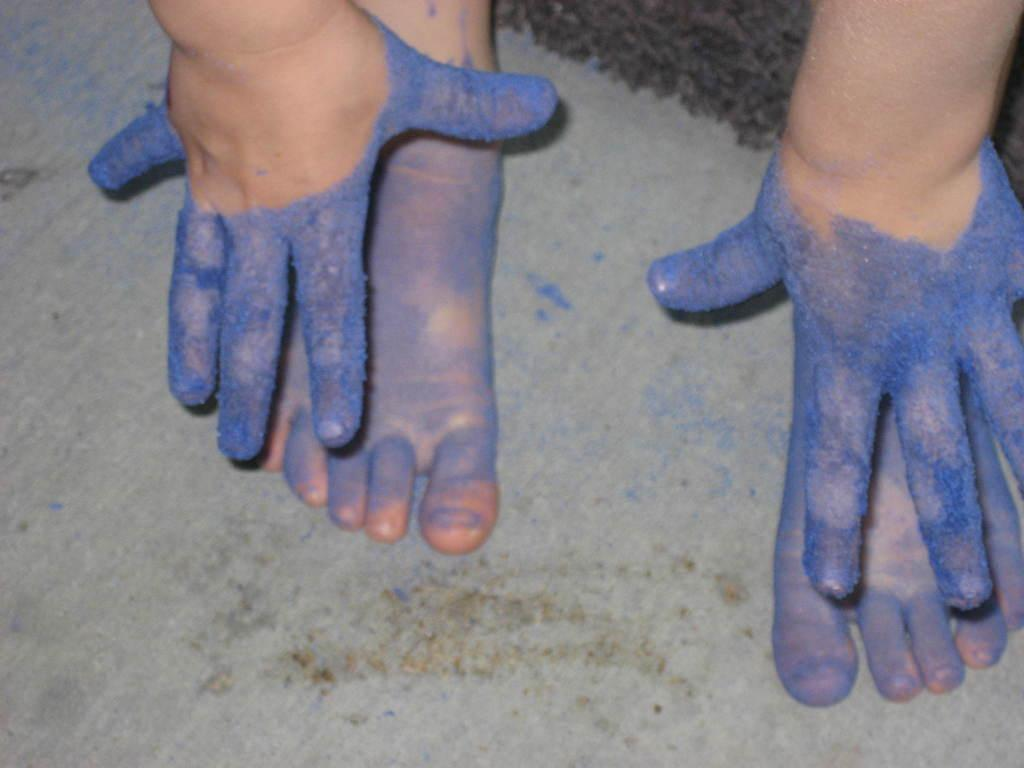What body parts of a kid are visible in the image? There are paws and feet of a kid in the image. What is the appearance of the paws and feet in the image? The paws and feet are dipped in blue color. Where is the nearest park to the location of the image? The provided facts do not give any information about the location of the image, so it is impossible to determine the nearest park. 